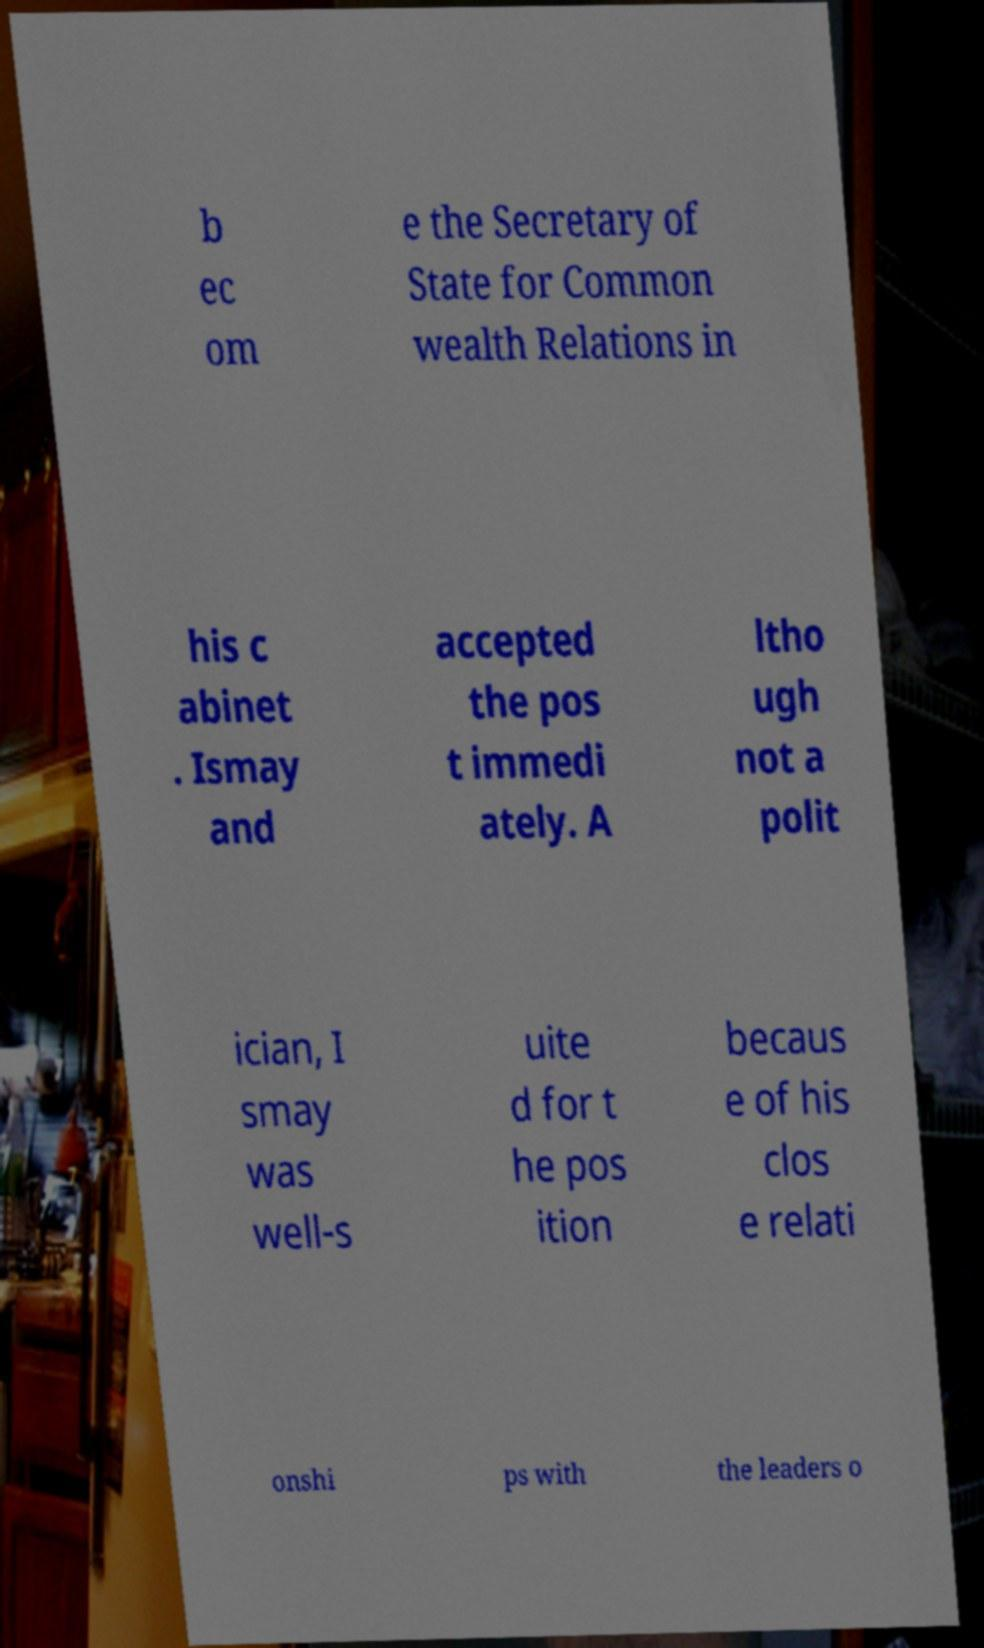Can you read and provide the text displayed in the image?This photo seems to have some interesting text. Can you extract and type it out for me? b ec om e the Secretary of State for Common wealth Relations in his c abinet . Ismay and accepted the pos t immedi ately. A ltho ugh not a polit ician, I smay was well-s uite d for t he pos ition becaus e of his clos e relati onshi ps with the leaders o 